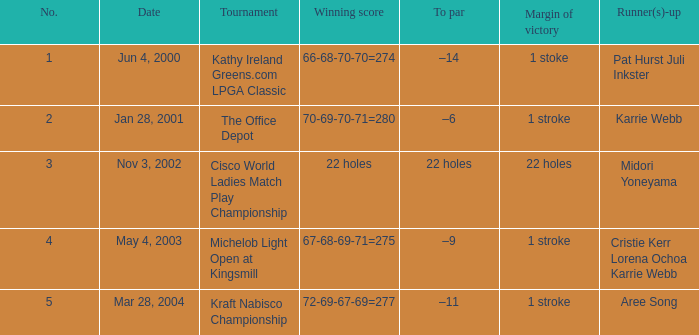What date were the runner ups pat hurst juli inkster? Jun 4, 2000. 